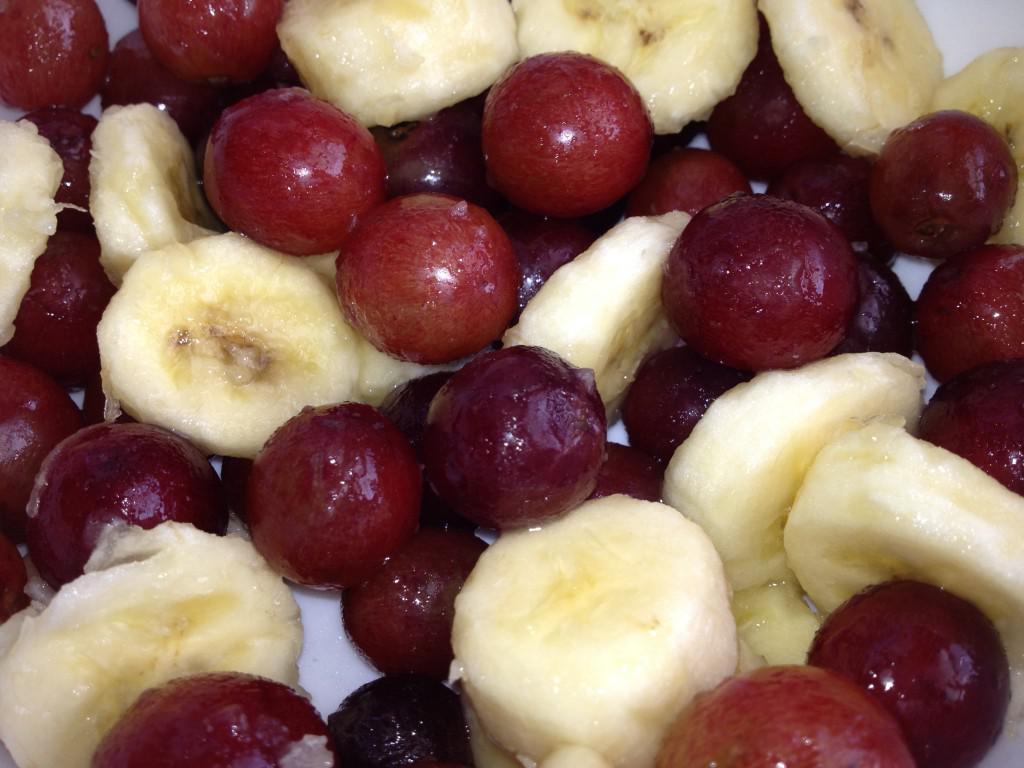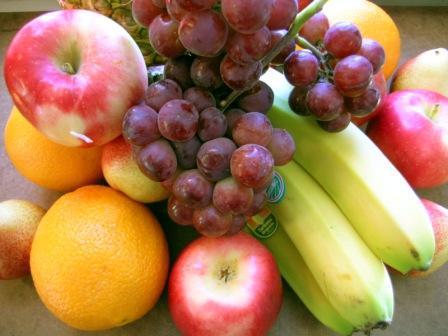The first image is the image on the left, the second image is the image on the right. For the images displayed, is the sentence "Some of the fruit is clearly in a bowl." factually correct? Answer yes or no. No. The first image is the image on the left, the second image is the image on the right. Evaluate the accuracy of this statement regarding the images: "A banana with its peel on is next to a bunch of reddish grapes in the right image.". Is it true? Answer yes or no. Yes. 